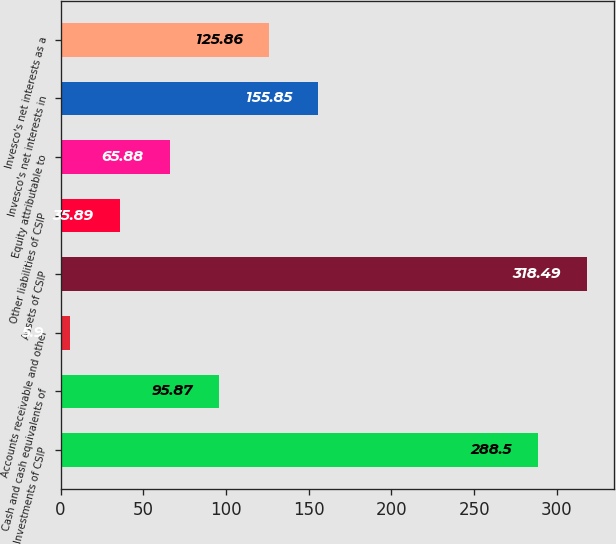Convert chart to OTSL. <chart><loc_0><loc_0><loc_500><loc_500><bar_chart><fcel>Investments of CSIP<fcel>Cash and cash equivalents of<fcel>Accounts receivable and other<fcel>Assets of CSIP<fcel>Other liabilities of CSIP<fcel>Equity attributable to<fcel>Invesco's net interests in<fcel>Invesco's net interests as a<nl><fcel>288.5<fcel>95.87<fcel>5.9<fcel>318.49<fcel>35.89<fcel>65.88<fcel>155.85<fcel>125.86<nl></chart> 